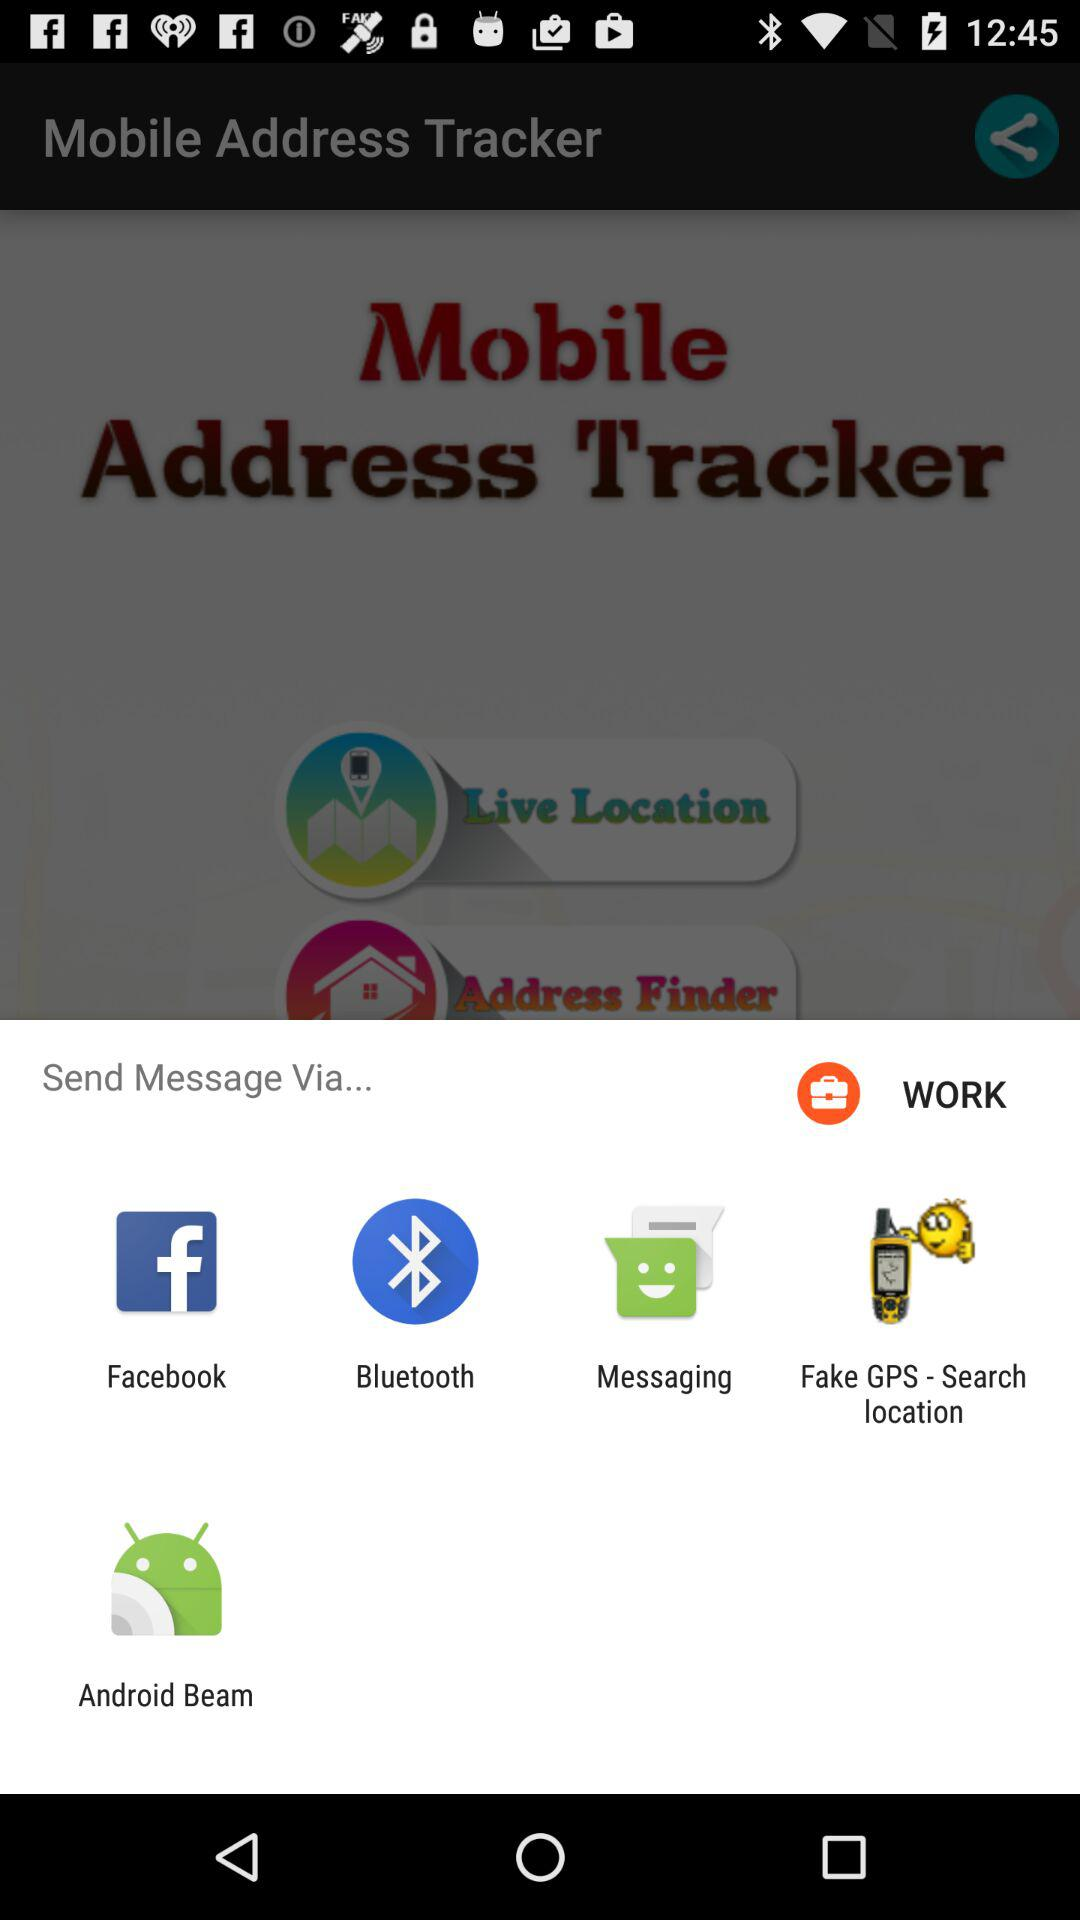What are the different options available for sending messages? The different options available for sending messages are "Facebook", "Bluetooth", "Messaging", "Fake GPS - Search location" and "Android Beam". 